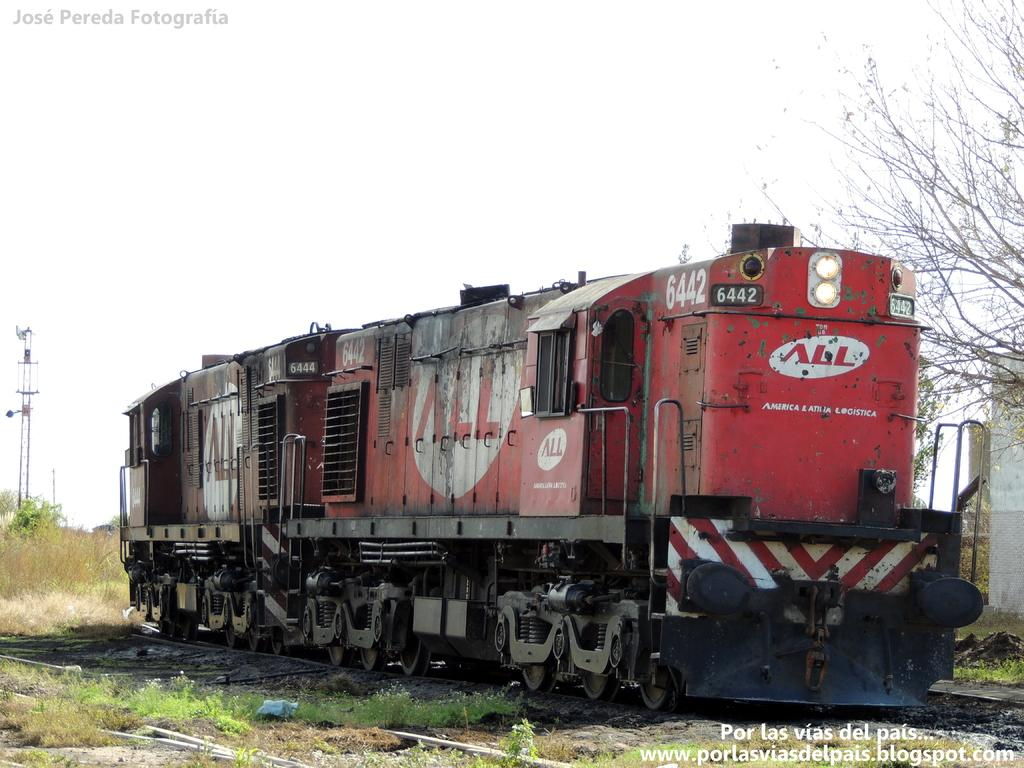What is the main subject of the image? The main subject of the image is a train. Where is the train located in the image? The train is on a track. What can be seen beside the track in the image? There are trees and grass visible beside the track. What other structures are present in the image? There are towers in the image. What type of lamp is hanging from the train in the image? There is no lamp hanging from the train in the image; it is a train on a track with trees and towers nearby. 